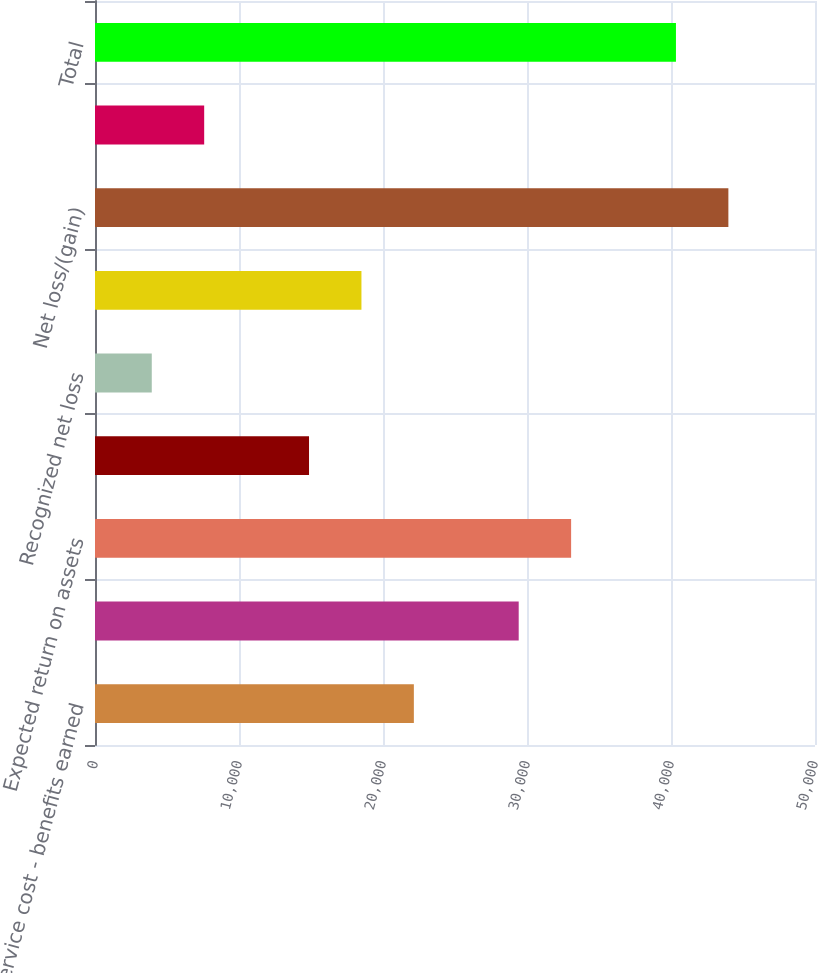Convert chart. <chart><loc_0><loc_0><loc_500><loc_500><bar_chart><fcel>Service cost - benefits earned<fcel>Interest cost on projected<fcel>Expected return on assets<fcel>Amortization of prior service<fcel>Recognized net loss<fcel>Net pension cost/(income)<fcel>Net loss/(gain)<fcel>Amortization of net loss<fcel>Total<nl><fcel>22143.2<fcel>29423.6<fcel>33063.8<fcel>14862.8<fcel>3942.2<fcel>18503<fcel>43984.4<fcel>7582.4<fcel>40344.2<nl></chart> 